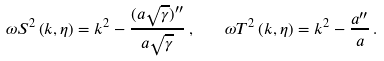<formula> <loc_0><loc_0><loc_500><loc_500>\omega S ^ { 2 } \left ( k , \eta \right ) = k ^ { 2 } - \frac { ( a \sqrt { \gamma } ) ^ { \prime \prime } } { a \sqrt { \gamma } } \, , \quad \omega T ^ { 2 } \left ( k , \eta \right ) = k ^ { 2 } - \frac { a ^ { \prime \prime } } { a } \, .</formula> 